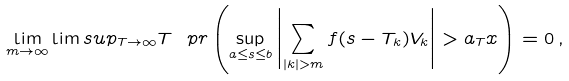Convert formula to latex. <formula><loc_0><loc_0><loc_500><loc_500>\lim _ { m \to \infty } \lim s u p _ { T \to \infty } T \ p r \left ( \sup _ { a \leq s \leq b } \left | \sum _ { | k | > m } f ( s - T _ { k } ) V _ { k } \right | > a _ { T } x \right ) = 0 \, ,</formula> 